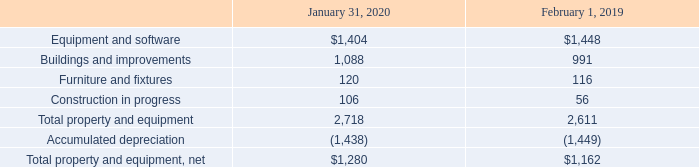M. Property and Equipment, Net
Property and equipment, net, as of the periods presented consisted of the following (table in millions):
As of January 31, 2020, construction in progress primarily represented various buildings and site improvements that had not yet been placed into service.
Depreciation expense was $234 million, $211 million and $206 million during the years ended January 31, 2020, February 1, 2019 and February 2, 2018, respectively.
What did construction in progress primarily represented as of 2020? Various buildings and site improvements that had not yet been placed into service. What was the depreciation expense in 2020? $234 million. What was the amount of construction in progress in 2020?
Answer scale should be: million. 106. What was the change in Total property and equipment between 2019 and 2020?
Answer scale should be: million. 2,718-2,611
Answer: 107. Which years did construction in progress exceed $100 million? 2020
Answer: 1. What was the percentage change in the net total property and equipment between 2019 and 2020?
Answer scale should be: percent. (1,280-1,162)/1,162
Answer: 10.15. 